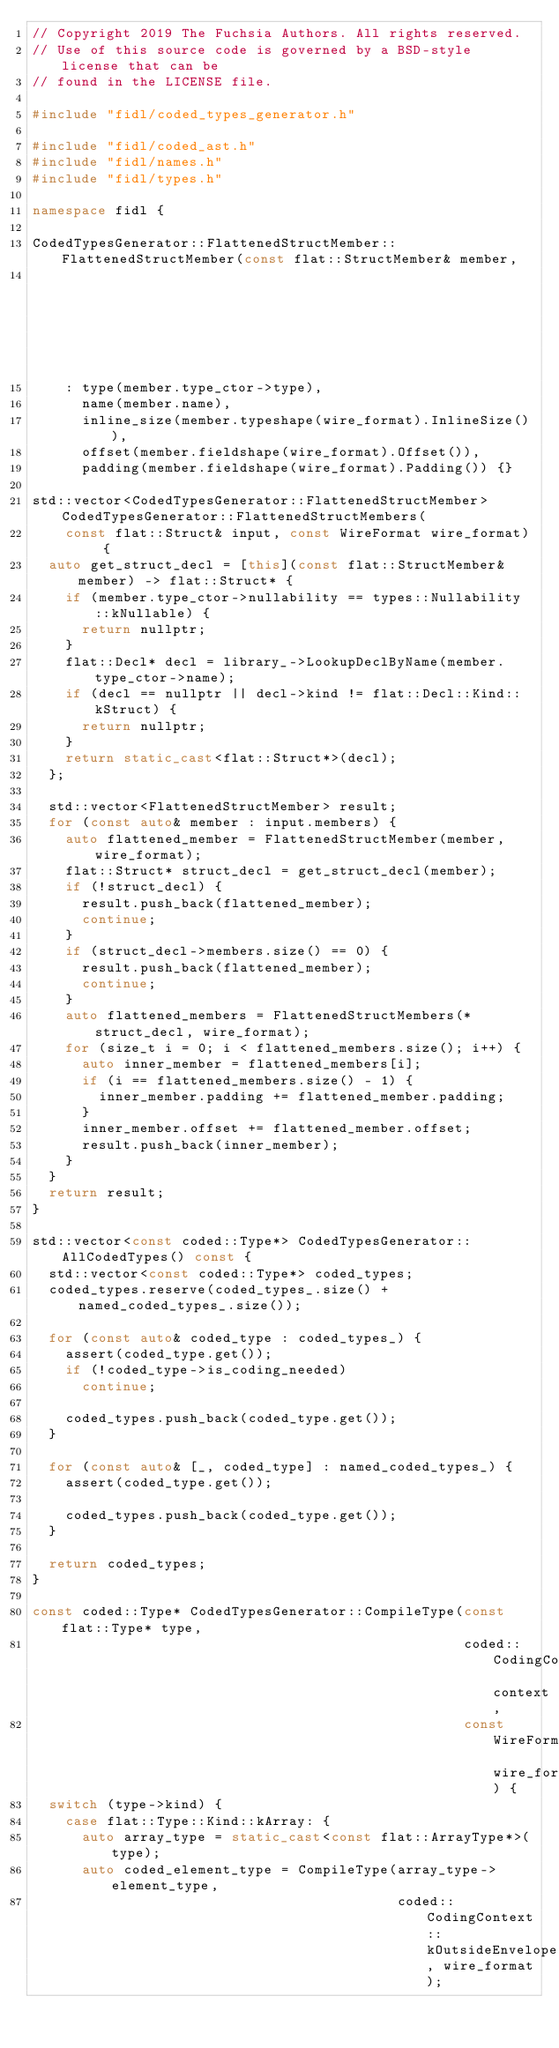<code> <loc_0><loc_0><loc_500><loc_500><_C++_>// Copyright 2019 The Fuchsia Authors. All rights reserved.
// Use of this source code is governed by a BSD-style license that can be
// found in the LICENSE file.

#include "fidl/coded_types_generator.h"

#include "fidl/coded_ast.h"
#include "fidl/names.h"
#include "fidl/types.h"

namespace fidl {

CodedTypesGenerator::FlattenedStructMember::FlattenedStructMember(const flat::StructMember& member,
                                                                  const WireFormat wire_format)
    : type(member.type_ctor->type),
      name(member.name),
      inline_size(member.typeshape(wire_format).InlineSize()),
      offset(member.fieldshape(wire_format).Offset()),
      padding(member.fieldshape(wire_format).Padding()) {}

std::vector<CodedTypesGenerator::FlattenedStructMember> CodedTypesGenerator::FlattenedStructMembers(
    const flat::Struct& input, const WireFormat wire_format) {
  auto get_struct_decl = [this](const flat::StructMember& member) -> flat::Struct* {
    if (member.type_ctor->nullability == types::Nullability::kNullable) {
      return nullptr;
    }
    flat::Decl* decl = library_->LookupDeclByName(member.type_ctor->name);
    if (decl == nullptr || decl->kind != flat::Decl::Kind::kStruct) {
      return nullptr;
    }
    return static_cast<flat::Struct*>(decl);
  };

  std::vector<FlattenedStructMember> result;
  for (const auto& member : input.members) {
    auto flattened_member = FlattenedStructMember(member, wire_format);
    flat::Struct* struct_decl = get_struct_decl(member);
    if (!struct_decl) {
      result.push_back(flattened_member);
      continue;
    }
    if (struct_decl->members.size() == 0) {
      result.push_back(flattened_member);
      continue;
    }
    auto flattened_members = FlattenedStructMembers(*struct_decl, wire_format);
    for (size_t i = 0; i < flattened_members.size(); i++) {
      auto inner_member = flattened_members[i];
      if (i == flattened_members.size() - 1) {
        inner_member.padding += flattened_member.padding;
      }
      inner_member.offset += flattened_member.offset;
      result.push_back(inner_member);
    }
  }
  return result;
}

std::vector<const coded::Type*> CodedTypesGenerator::AllCodedTypes() const {
  std::vector<const coded::Type*> coded_types;
  coded_types.reserve(coded_types_.size() + named_coded_types_.size());

  for (const auto& coded_type : coded_types_) {
    assert(coded_type.get());
    if (!coded_type->is_coding_needed)
      continue;

    coded_types.push_back(coded_type.get());
  }

  for (const auto& [_, coded_type] : named_coded_types_) {
    assert(coded_type.get());

    coded_types.push_back(coded_type.get());
  }

  return coded_types;
}

const coded::Type* CodedTypesGenerator::CompileType(const flat::Type* type,
                                                    coded::CodingContext context,
                                                    const WireFormat wire_format) {
  switch (type->kind) {
    case flat::Type::Kind::kArray: {
      auto array_type = static_cast<const flat::ArrayType*>(type);
      auto coded_element_type = CompileType(array_type->element_type,
                                            coded::CodingContext::kOutsideEnvelope, wire_format);
</code> 